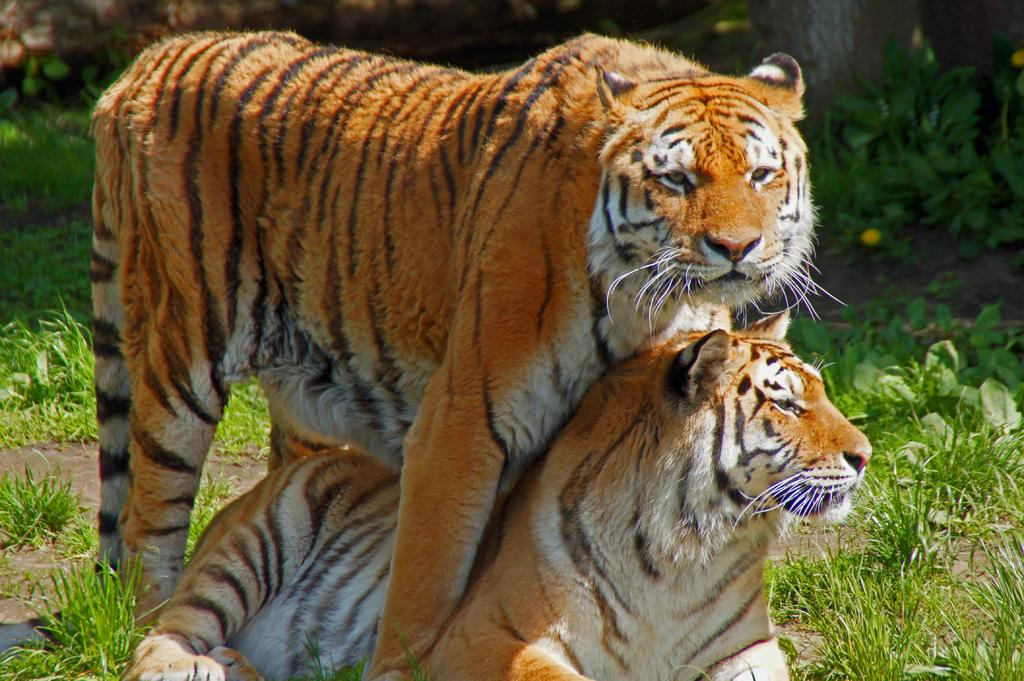How many tigers are in the picture? There are two tigers in the picture. What can be seen beside the tigers? There are plants present beside the tigers. What type of steel structure can be seen in the background of the image? There is no steel structure present in the image; it features two tigers and plants. How many chickens are visible in the image? There are no chickens present in the image. 